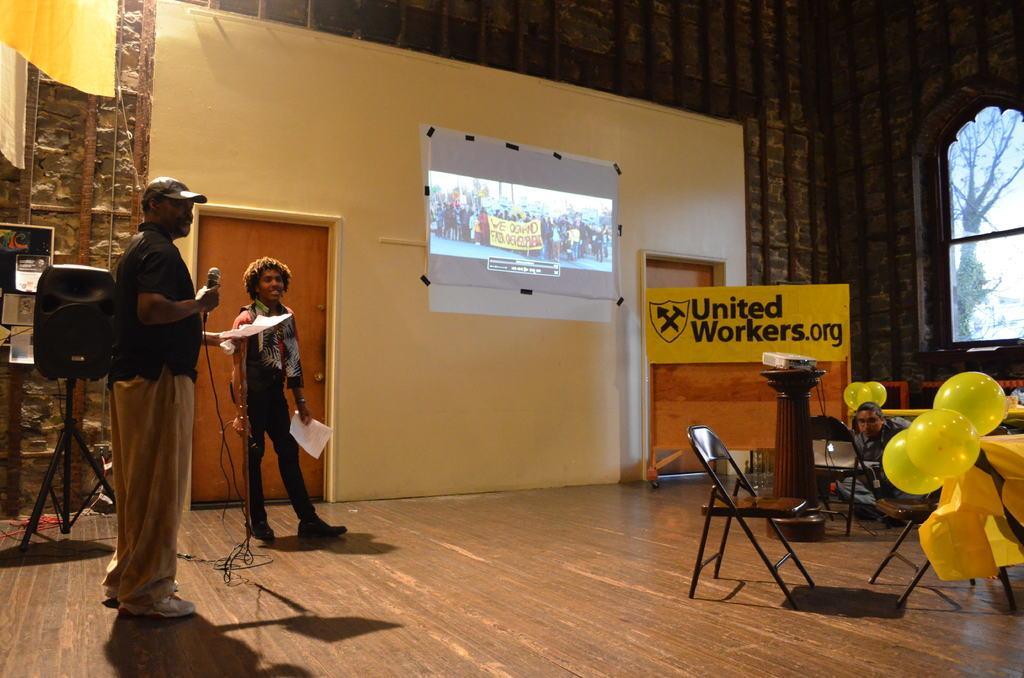Describe this image in one or two sentences. In this image there is a wall with projector screen on it, beside that there are doors, also there are two people standing on the floor in which one of them is holding microphone and papers, there is a table with balloons tied at the edge and there are chairs beside that. 